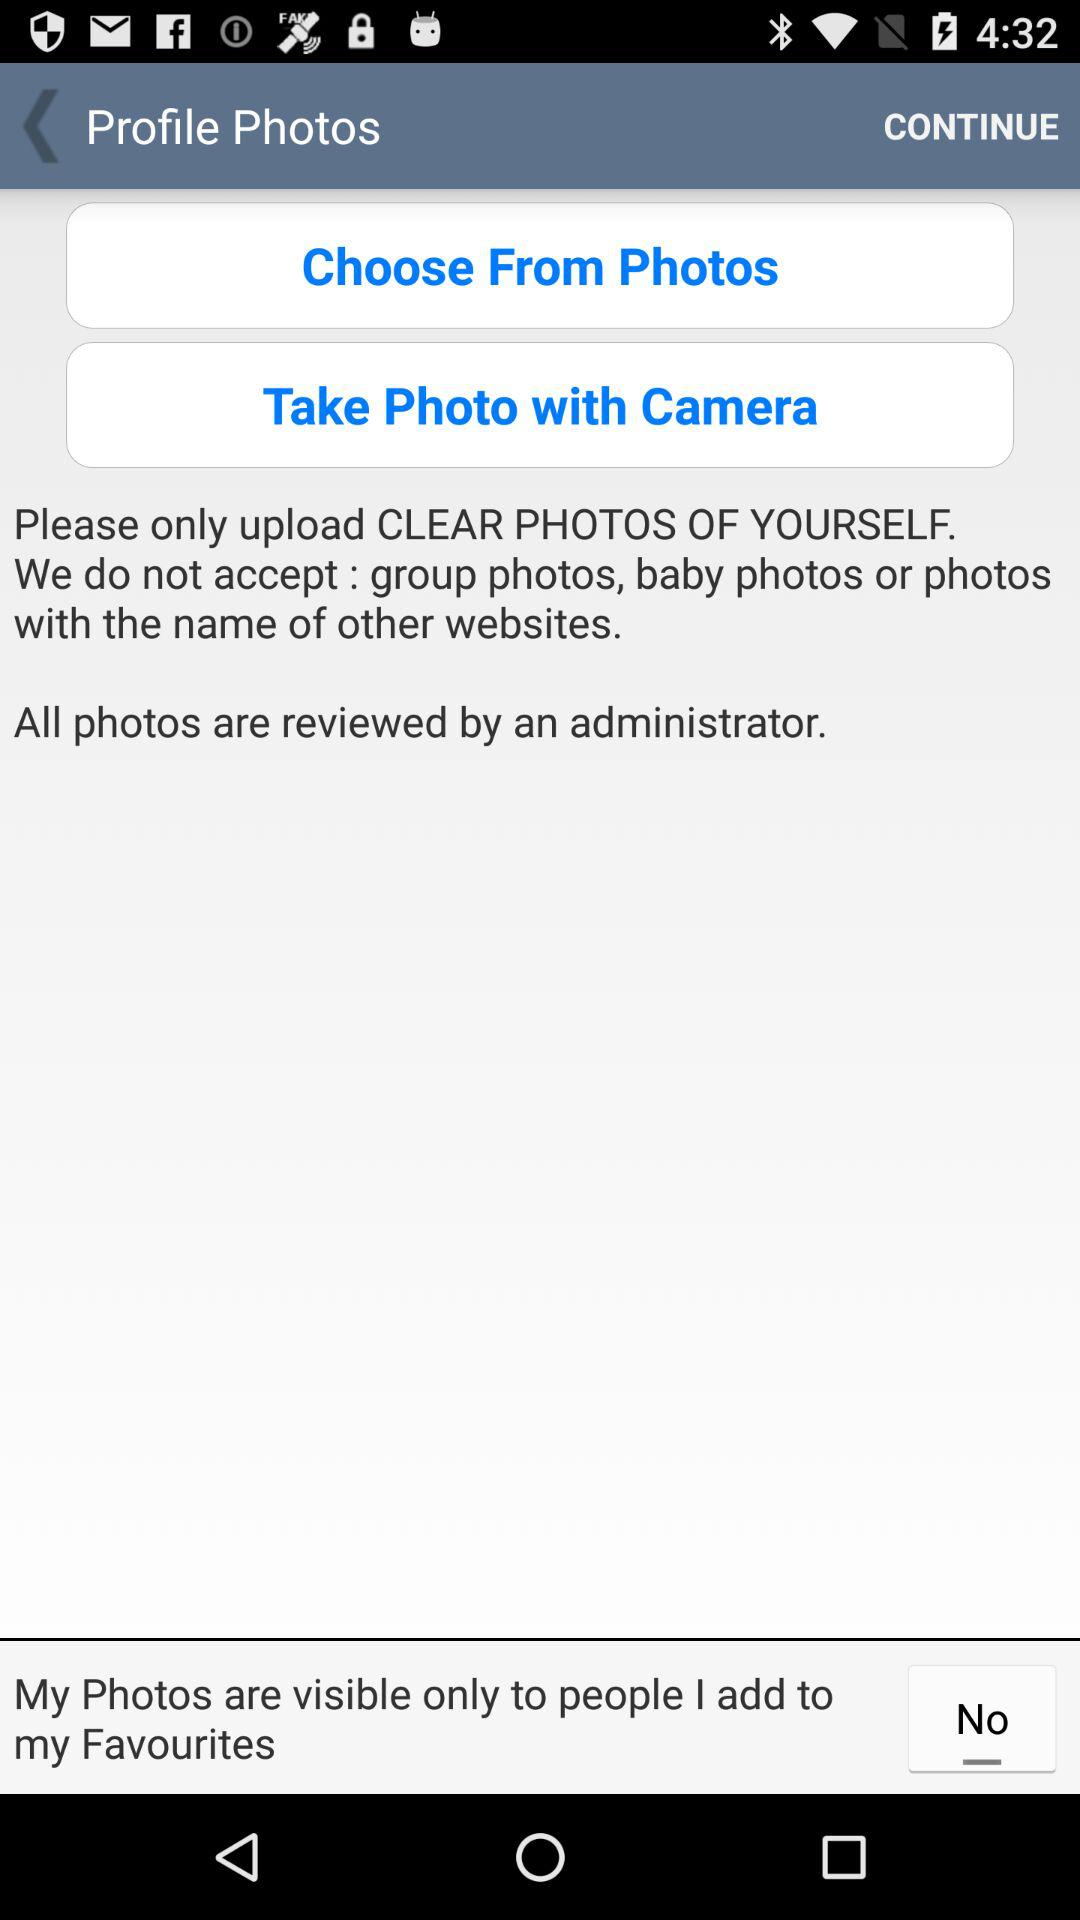Who did I add to my favorites?
When the provided information is insufficient, respond with <no answer>. <no answer> 